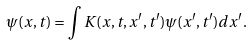<formula> <loc_0><loc_0><loc_500><loc_500>\psi ( x , t ) = \int K ( x , t , x ^ { \prime } , t ^ { \prime } ) \psi ( x ^ { \prime } , t ^ { \prime } ) d x ^ { \prime } .</formula> 